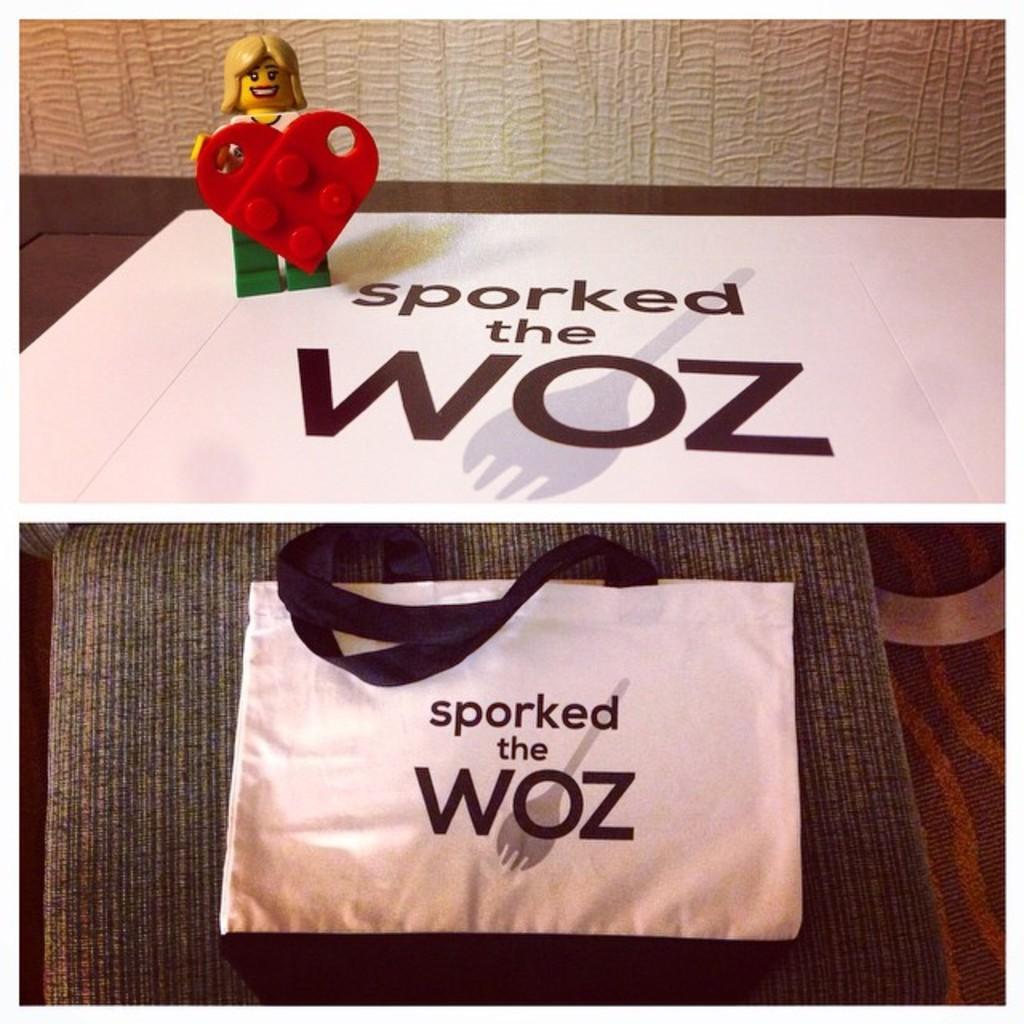How would you summarize this image in a sentence or two? In the picture I can see a bag and a toy on a white color surface. I can also see something written on white color objects. This is a collage image. 